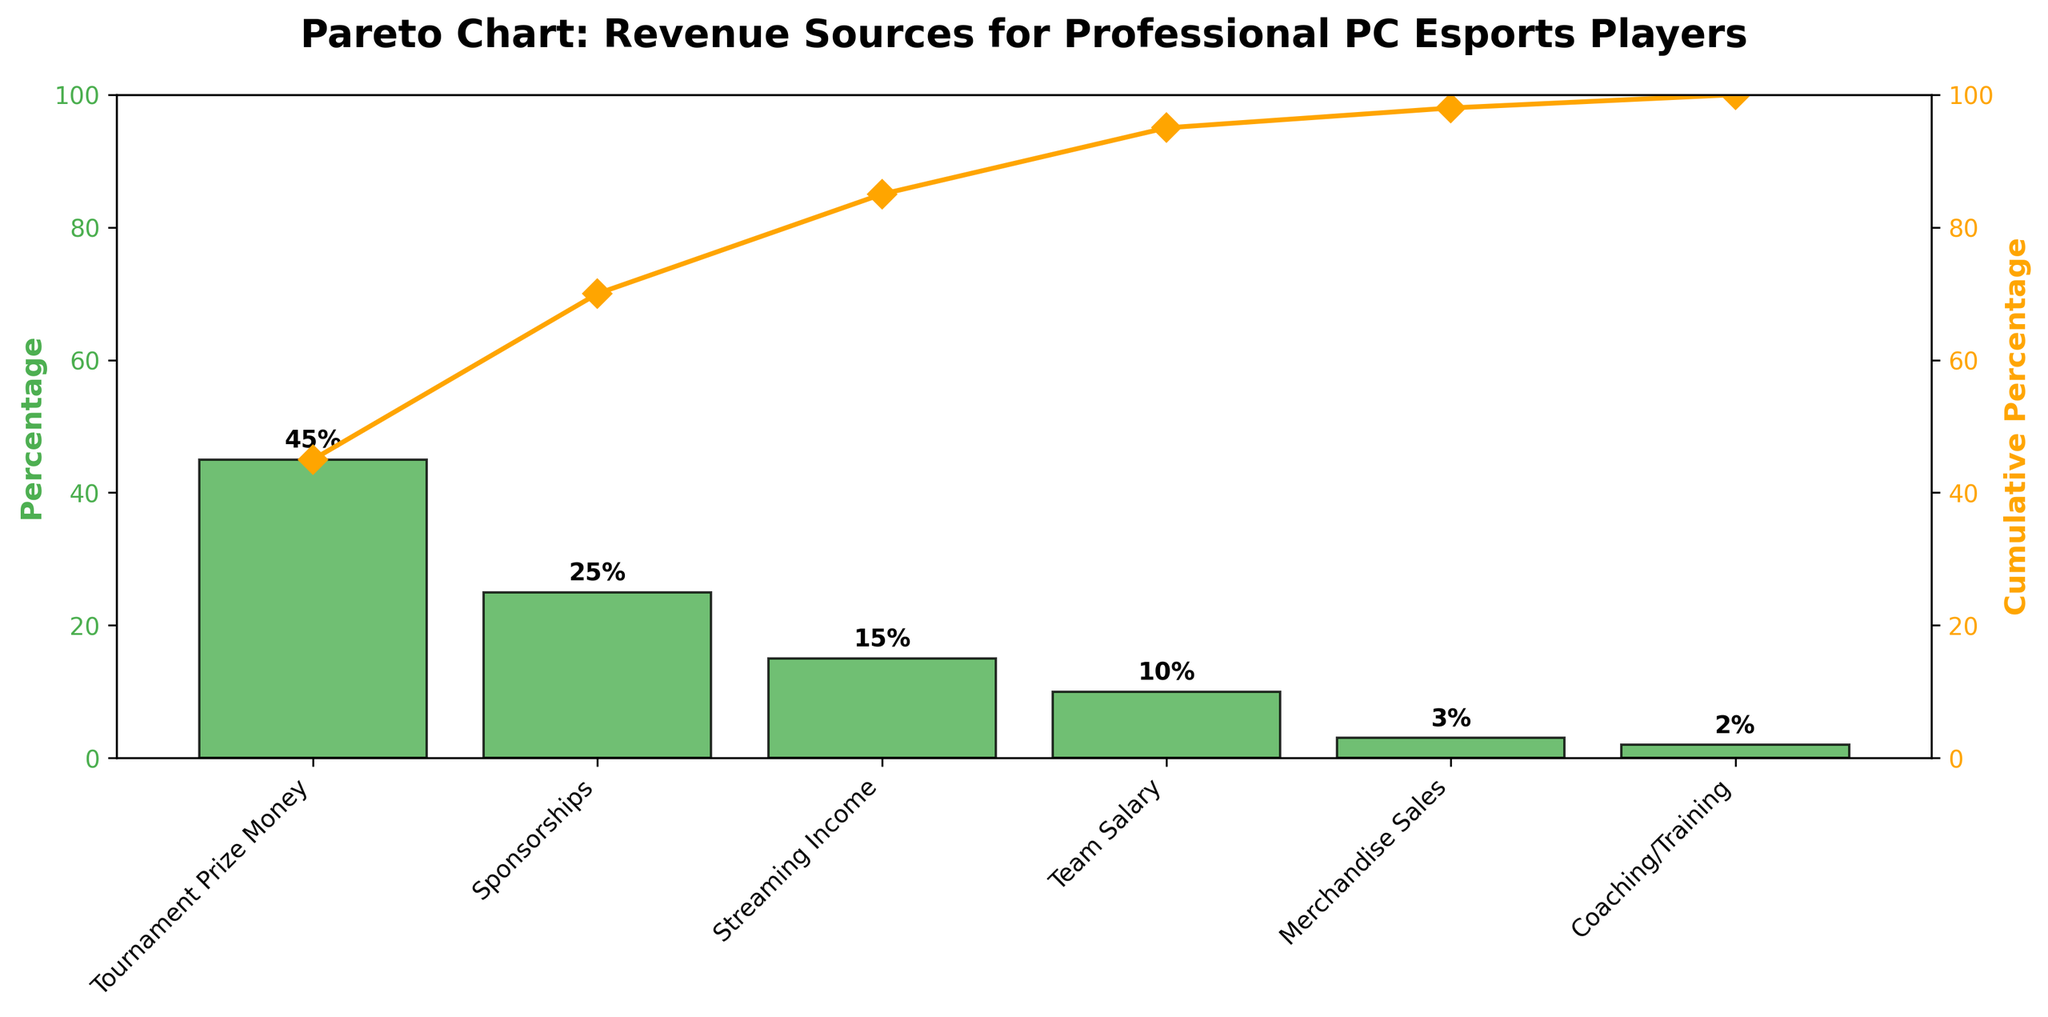What is the title of the chart? The title is written at the top of the chart.
Answer: Pareto Chart: Revenue Sources for Professional PC Esports Players Which revenue source contributes the highest percentage? The tallest bar represents the highest percentage, indicated by "Tournament Prize Money."
Answer: Tournament Prize Money What is the cumulative percentage up to and including Streaming Income? Identify the cumulative percentage line and follow it up to the "Streaming Income" label.
Answer: 85% Which revenue sources together contribute exactly 70% to the total revenue? Sum the percentages sequentially from the top until the total reaches 70%.
Answer: Tournament Prize Money, Sponsorships, Streaming Income What's the cumulative percentage after Team Salary is included? Add the cumulative value for Team Salary to previous cumulative percentages.
Answer: 95% Compare the contributions of Team Salary and Merchandise Sales. Which one contributes more, and by what percentage? Compare the heights of the bars for Team Salary and Merchandise Sales.
Answer: Team Salary contributes more by 7% How does the contribution of Coaching/Training compare to the top revenue source? Evaluate the percentage difference between Coaching/Training and the top revenue source.
Answer: Coaching/Training contributes 43% less What is the percentage contribution of all revenue sources other than Tournament Prize Money? Subtract the percentage of Tournament Prize Money from 100%.
Answer: 55% What percentage of the total revenue is contributed by the bottom three sources combined? Sum the percentages of Merchandise Sales, Coaching/Training, and Team Salary.
Answer: 15% What color are the bars representing each revenue source? The bars are all the same color, visually identified on the chart.
Answer: Green 